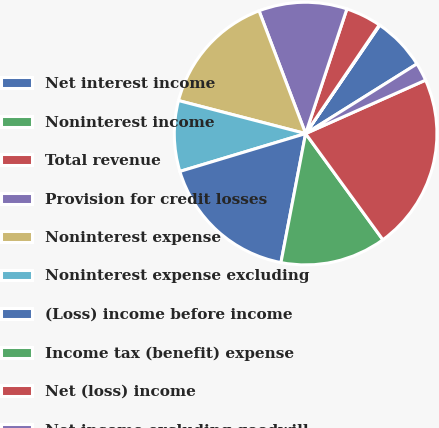Convert chart to OTSL. <chart><loc_0><loc_0><loc_500><loc_500><pie_chart><fcel>Net interest income<fcel>Noninterest income<fcel>Total revenue<fcel>Provision for credit losses<fcel>Noninterest expense<fcel>Noninterest expense excluding<fcel>(Loss) income before income<fcel>Income tax (benefit) expense<fcel>Net (loss) income<fcel>Net income excluding goodwill<nl><fcel>6.55%<fcel>0.07%<fcel>4.39%<fcel>10.86%<fcel>15.18%<fcel>8.7%<fcel>17.34%<fcel>13.02%<fcel>21.66%<fcel>2.23%<nl></chart> 